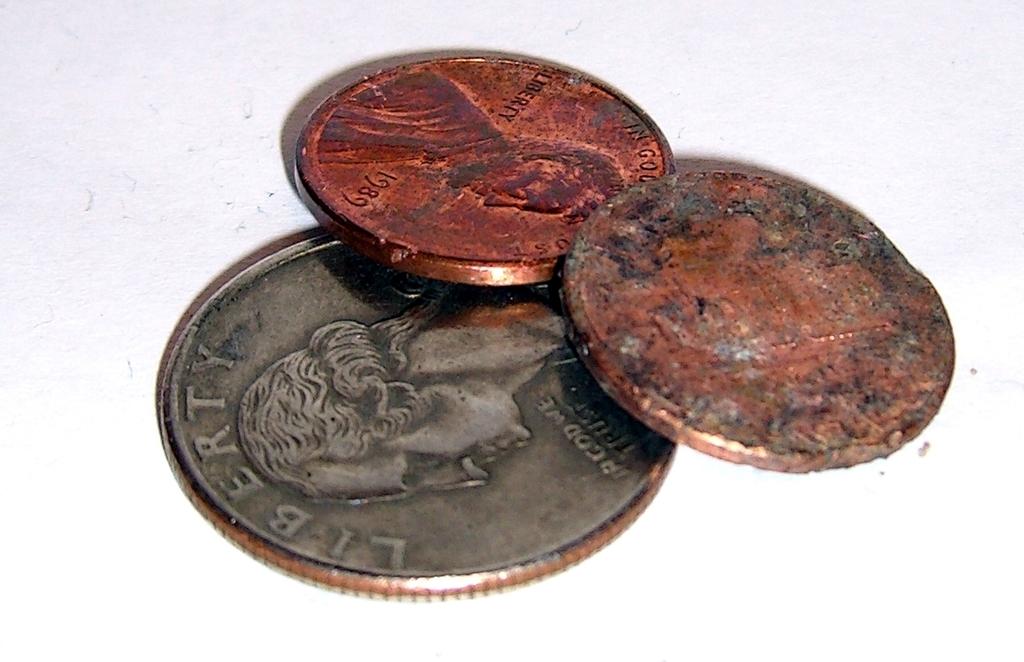What word is written above the head on the silver coin?
Offer a terse response. Liberty. 